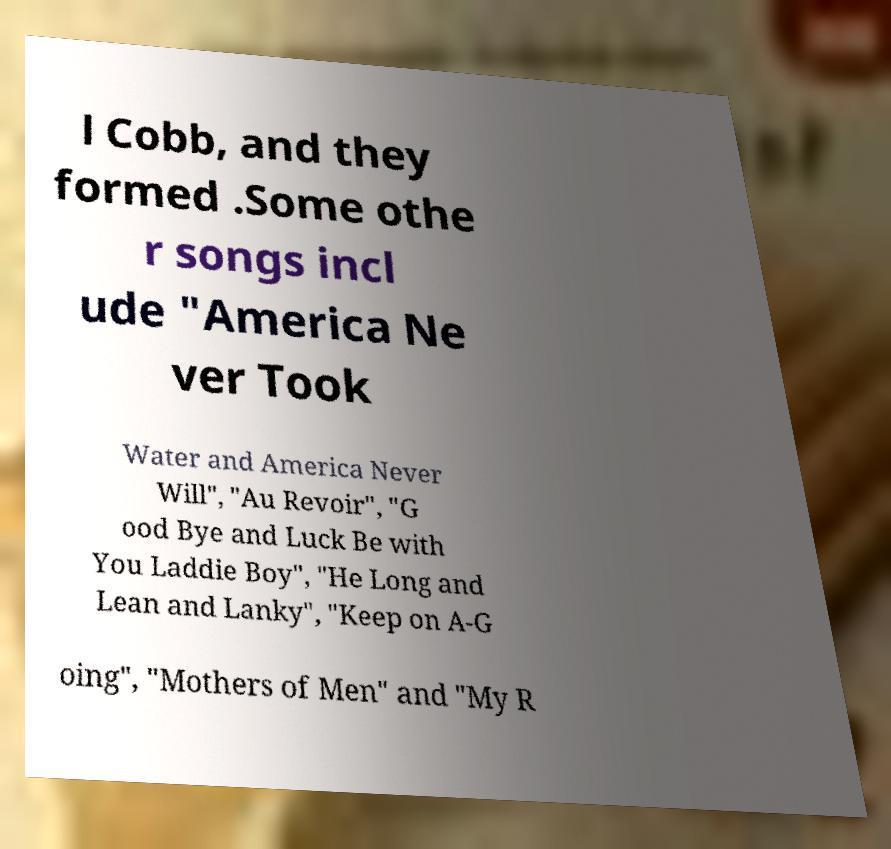Please read and relay the text visible in this image. What does it say? l Cobb, and they formed .Some othe r songs incl ude "America Ne ver Took Water and America Never Will", "Au Revoir", "G ood Bye and Luck Be with You Laddie Boy", "He Long and Lean and Lanky", "Keep on A-G oing", "Mothers of Men" and "My R 